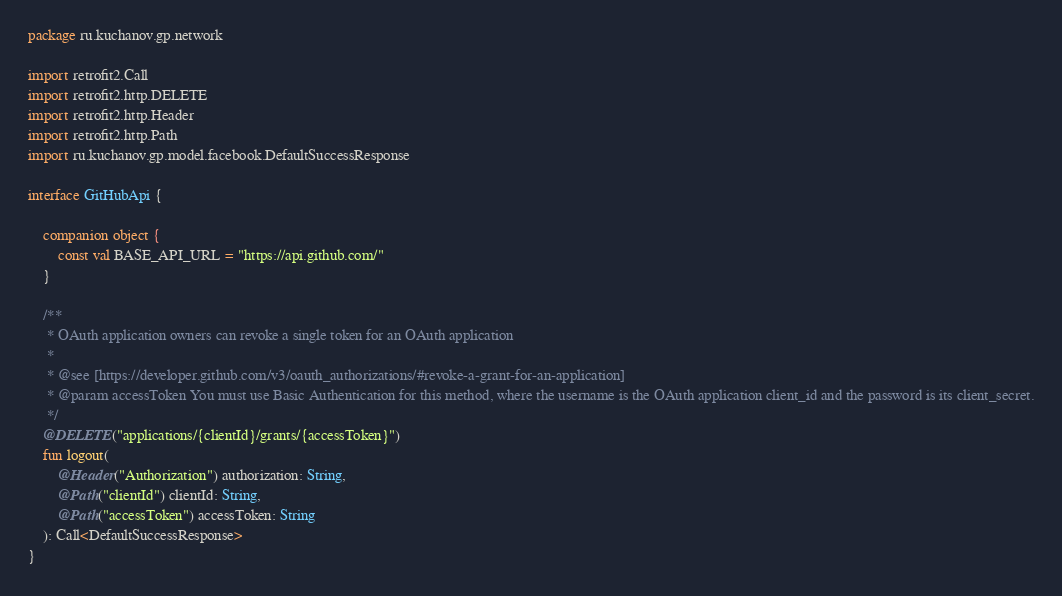<code> <loc_0><loc_0><loc_500><loc_500><_Kotlin_>package ru.kuchanov.gp.network

import retrofit2.Call
import retrofit2.http.DELETE
import retrofit2.http.Header
import retrofit2.http.Path
import ru.kuchanov.gp.model.facebook.DefaultSuccessResponse

interface GitHubApi {

    companion object {
        const val BASE_API_URL = "https://api.github.com/"
    }

    /**
     * OAuth application owners can revoke a single token for an OAuth application
     *
     * @see [https://developer.github.com/v3/oauth_authorizations/#revoke-a-grant-for-an-application]
     * @param accessToken You must use Basic Authentication for this method, where the username is the OAuth application client_id and the password is its client_secret.
     */
    @DELETE("applications/{clientId}/grants/{accessToken}")
    fun logout(
        @Header("Authorization") authorization: String,
        @Path("clientId") clientId: String,
        @Path("accessToken") accessToken: String
    ): Call<DefaultSuccessResponse>
}
</code> 